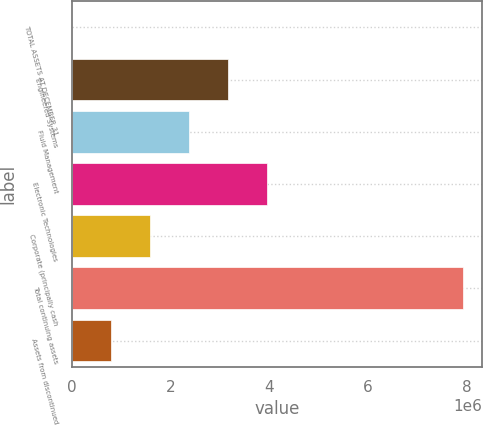<chart> <loc_0><loc_0><loc_500><loc_500><bar_chart><fcel>TOTAL ASSETS AT DECEMBER 31<fcel>Engineered Systems<fcel>Fluid Management<fcel>Electronic Technologies<fcel>Corporate (principally cash<fcel>Total continuing assets<fcel>Assets from discontinued<nl><fcel>2007<fcel>3.16746e+06<fcel>2.3761e+06<fcel>3.95883e+06<fcel>1.58474e+06<fcel>7.91565e+06<fcel>793371<nl></chart> 